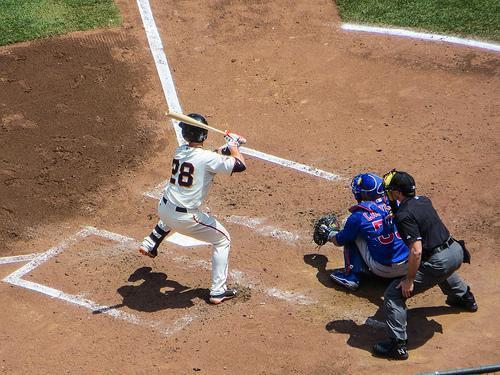How many men are there?
Give a very brief answer. 3. 